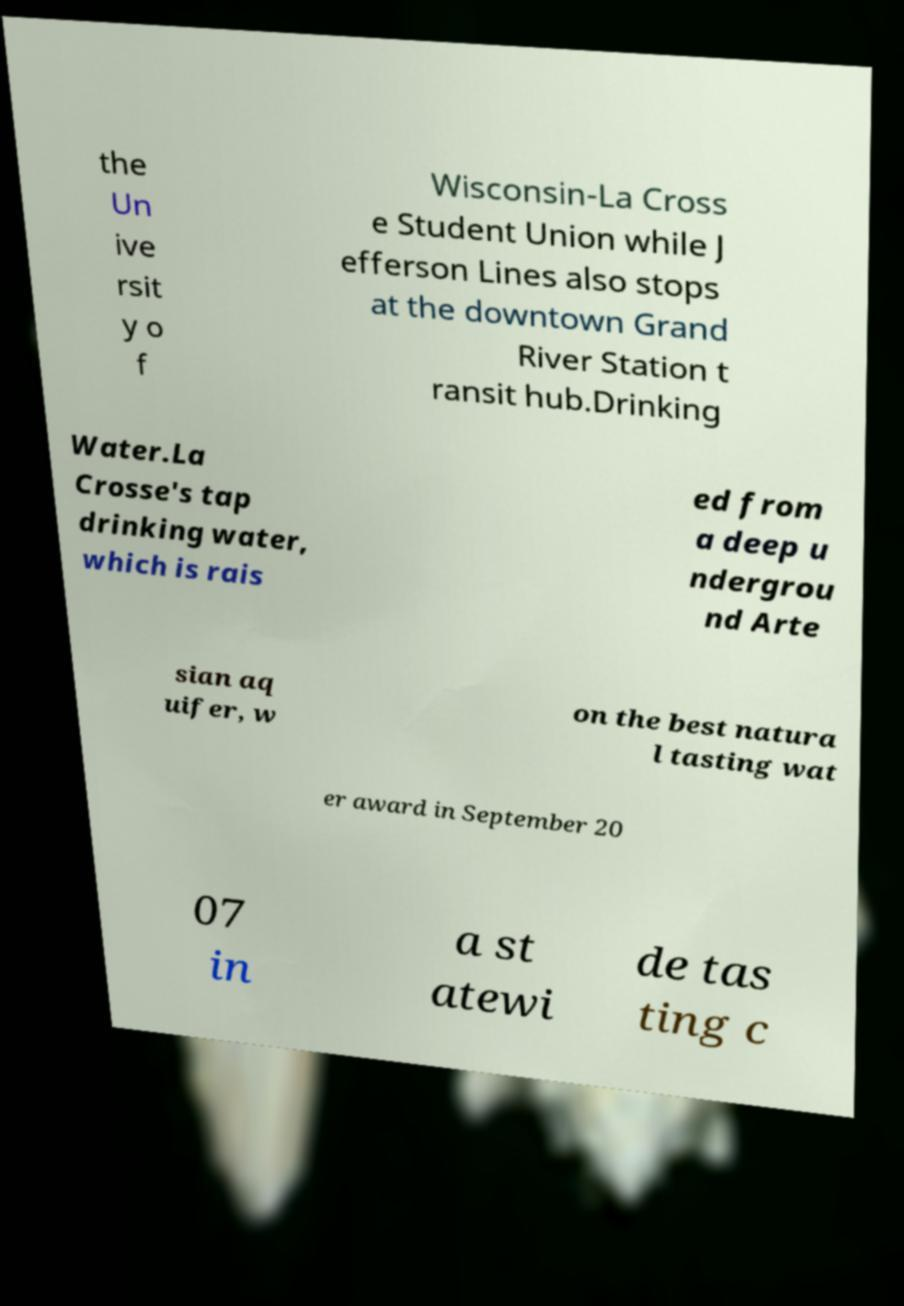Can you accurately transcribe the text from the provided image for me? the Un ive rsit y o f Wisconsin-La Cross e Student Union while J efferson Lines also stops at the downtown Grand River Station t ransit hub.Drinking Water.La Crosse's tap drinking water, which is rais ed from a deep u ndergrou nd Arte sian aq uifer, w on the best natura l tasting wat er award in September 20 07 in a st atewi de tas ting c 